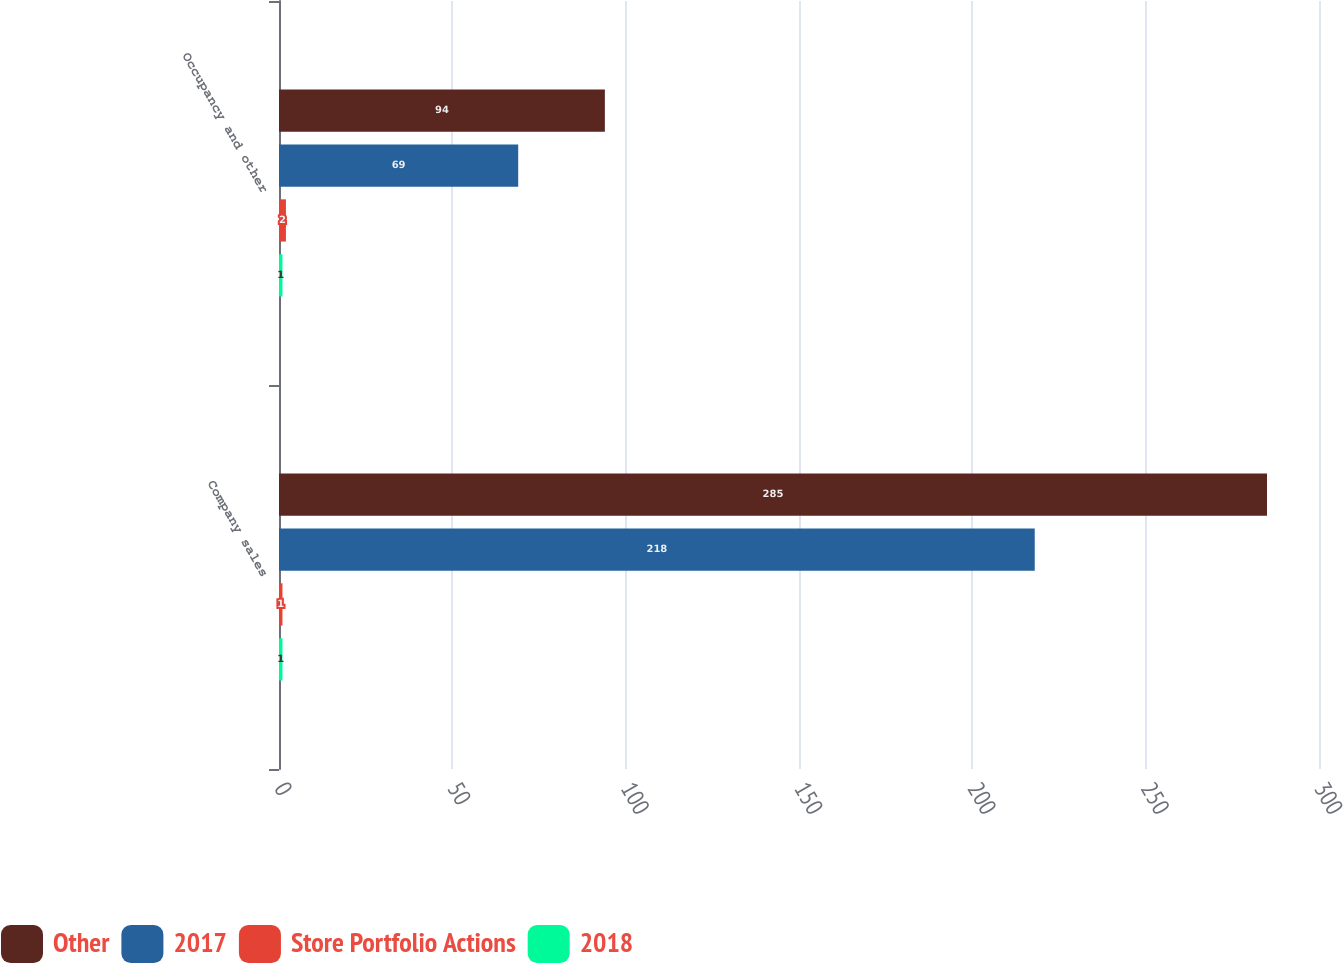<chart> <loc_0><loc_0><loc_500><loc_500><stacked_bar_chart><ecel><fcel>Company sales<fcel>Occupancy and other<nl><fcel>Other<fcel>285<fcel>94<nl><fcel>2017<fcel>218<fcel>69<nl><fcel>Store Portfolio Actions<fcel>1<fcel>2<nl><fcel>2018<fcel>1<fcel>1<nl></chart> 